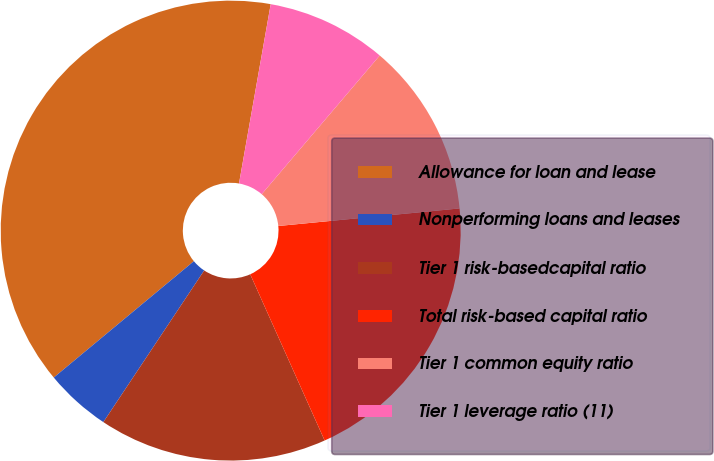Convert chart. <chart><loc_0><loc_0><loc_500><loc_500><pie_chart><fcel>Allowance for loan and lease<fcel>Nonperforming loans and leases<fcel>Tier 1 risk-basedcapital ratio<fcel>Total risk-based capital ratio<fcel>Tier 1 common equity ratio<fcel>Tier 1 leverage ratio (11)<nl><fcel>38.82%<fcel>4.63%<fcel>16.04%<fcel>19.84%<fcel>12.24%<fcel>8.44%<nl></chart> 